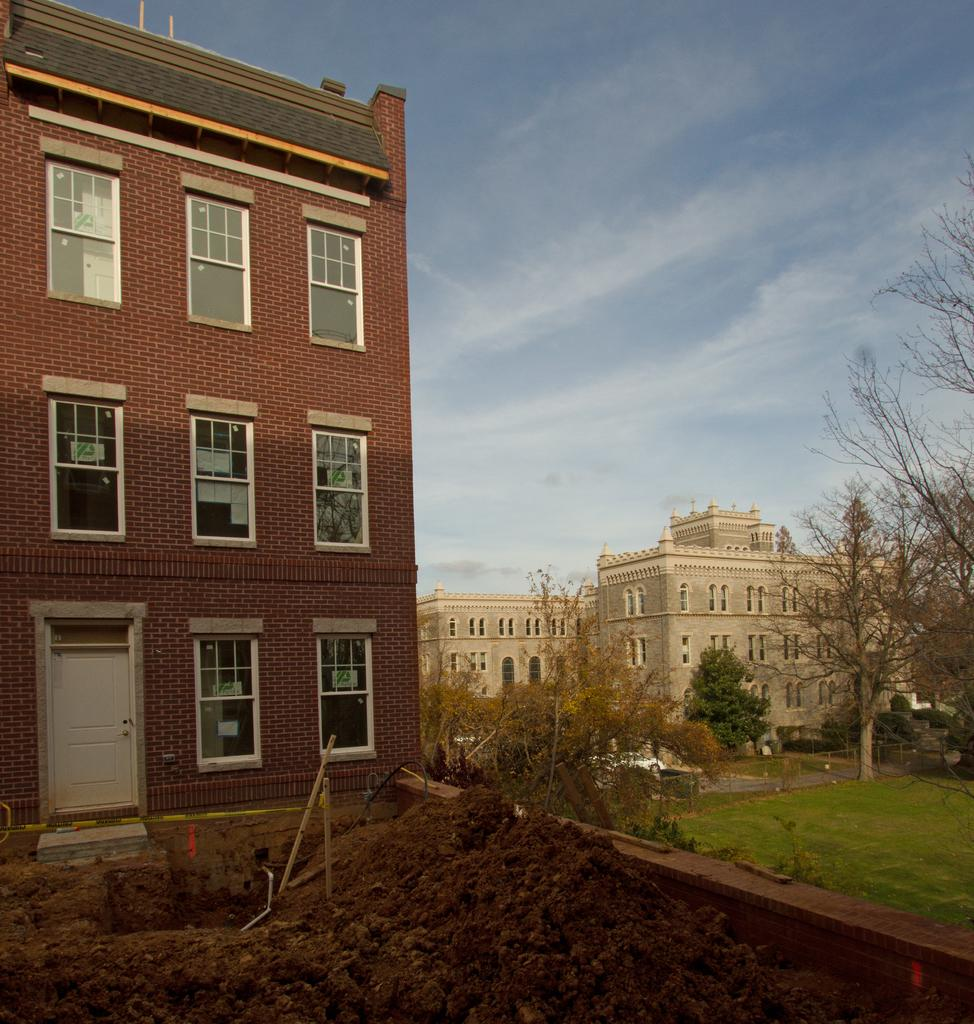What type of structures can be seen in the image? There are buildings in the image. What type of vegetation is present in the image? There are trees in the image. What objects made of wood can be seen in the image? There are wooden sticks in the image. What is at the bottom of the image? There is mud and a wall at the bottom of the image. What is visible at the top of the image? The sky is visible at the top of the image. How many people are jumping over the mountain in the image? There is no mountain or people jumping in the image. What is the size of the wooden sticks compared to the trees in the image? There is no information provided about the size of the wooden sticks or trees in the image. 